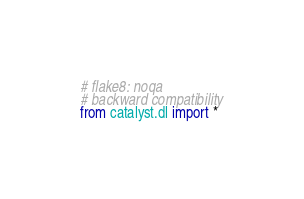Convert code to text. <code><loc_0><loc_0><loc_500><loc_500><_Python_># flake8: noqa
# backward compatibility
from catalyst.dl import *
</code> 